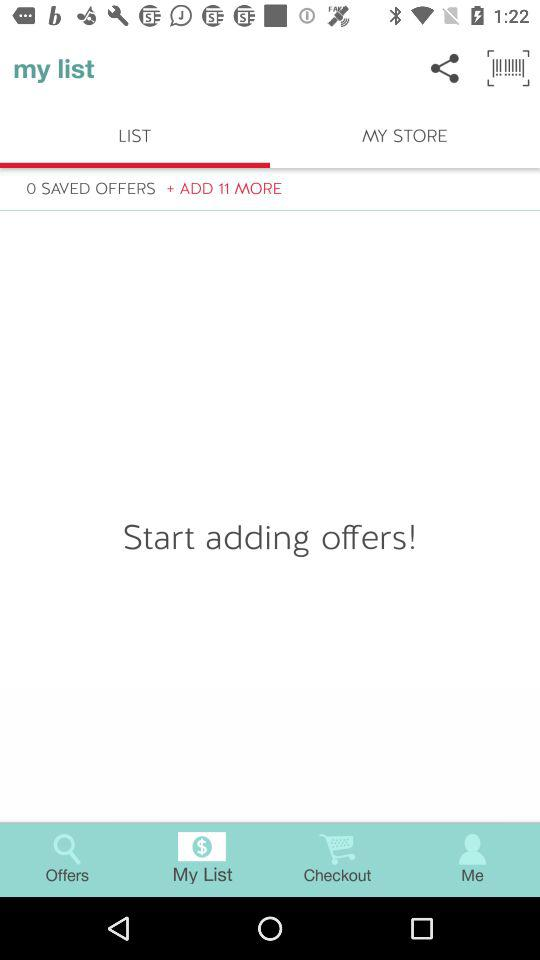Which tab is selected? The selected tab is "LIST". 